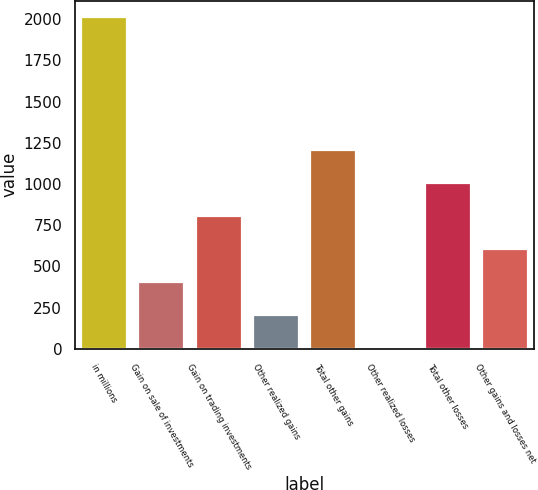Convert chart to OTSL. <chart><loc_0><loc_0><loc_500><loc_500><bar_chart><fcel>in millions<fcel>Gain on sale of investments<fcel>Gain on trading investments<fcel>Other realized gains<fcel>Total other gains<fcel>Other realized losses<fcel>Total other losses<fcel>Other gains and losses net<nl><fcel>2012<fcel>404.48<fcel>806.36<fcel>203.54<fcel>1208.24<fcel>2.6<fcel>1007.3<fcel>605.42<nl></chart> 